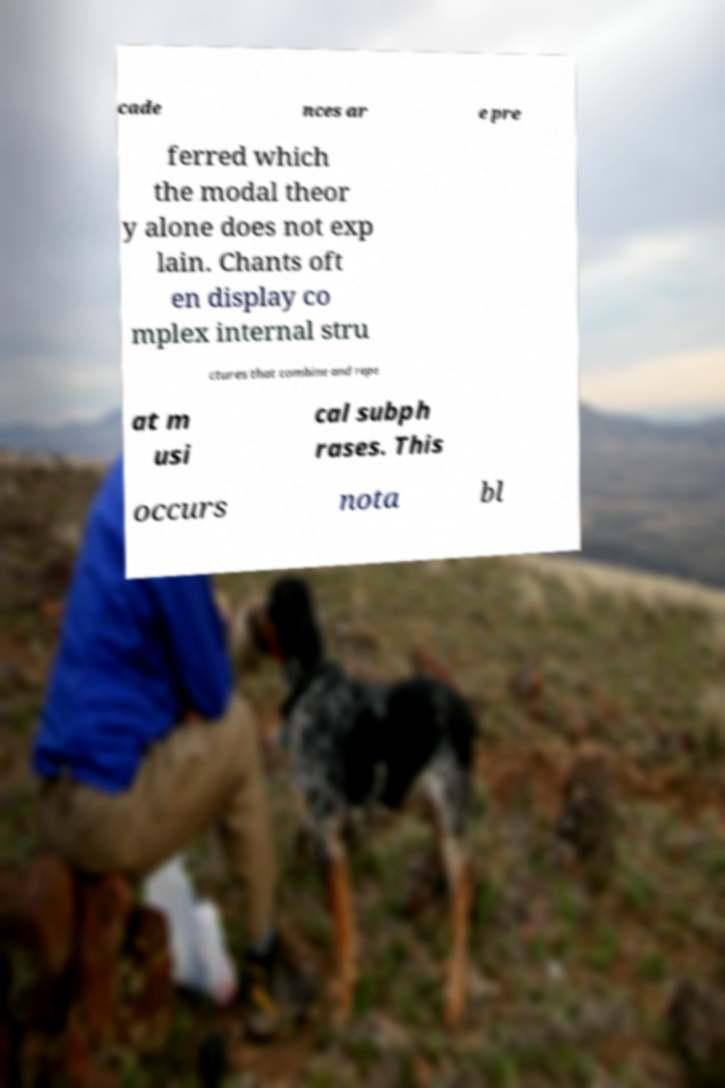Please read and relay the text visible in this image. What does it say? cade nces ar e pre ferred which the modal theor y alone does not exp lain. Chants oft en display co mplex internal stru ctures that combine and repe at m usi cal subph rases. This occurs nota bl 